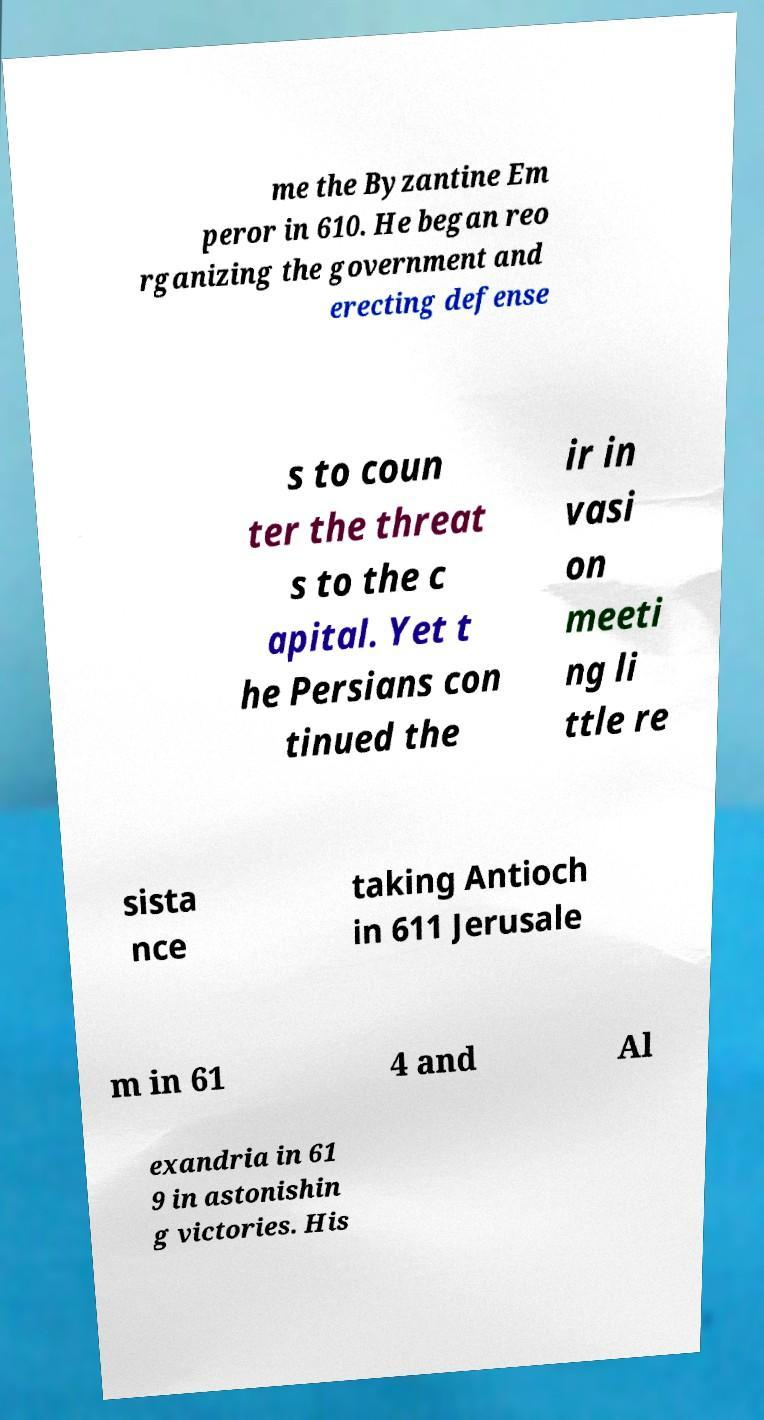Could you assist in decoding the text presented in this image and type it out clearly? me the Byzantine Em peror in 610. He began reo rganizing the government and erecting defense s to coun ter the threat s to the c apital. Yet t he Persians con tinued the ir in vasi on meeti ng li ttle re sista nce taking Antioch in 611 Jerusale m in 61 4 and Al exandria in 61 9 in astonishin g victories. His 